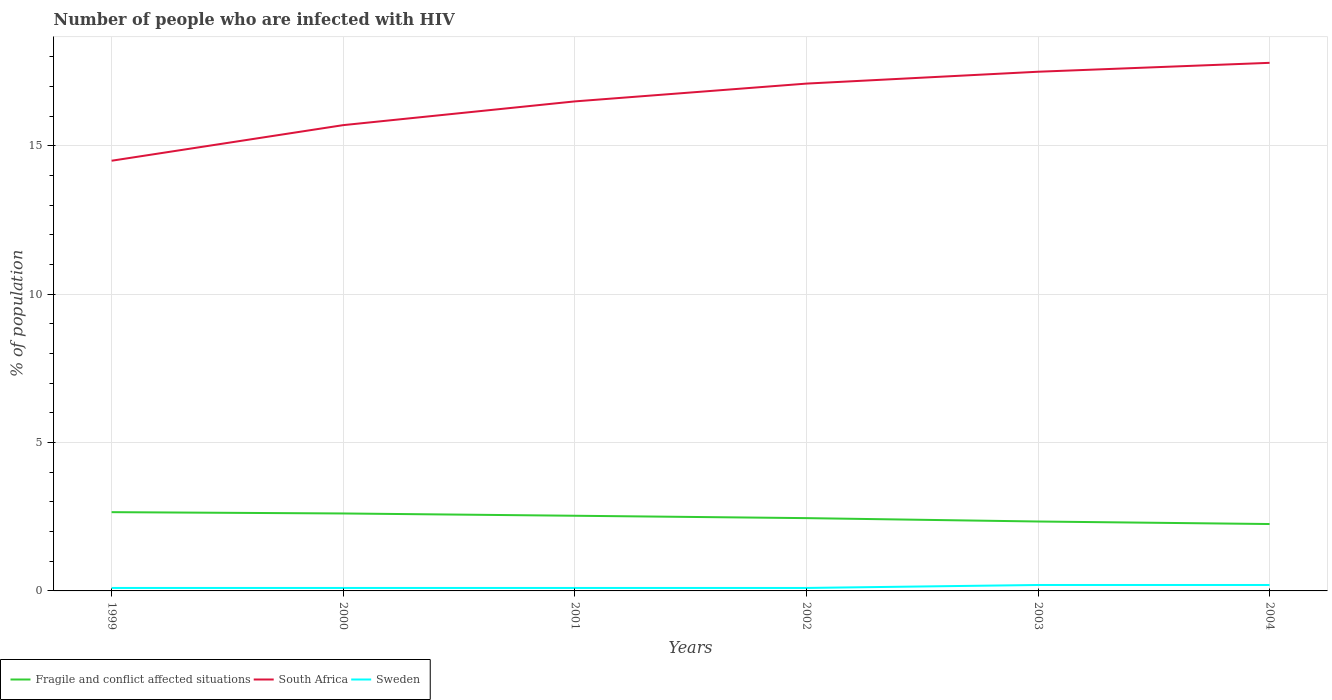Is the number of lines equal to the number of legend labels?
Give a very brief answer. Yes. Across all years, what is the maximum percentage of HIV infected population in in Fragile and conflict affected situations?
Your answer should be very brief. 2.25. In which year was the percentage of HIV infected population in in Sweden maximum?
Provide a short and direct response. 1999. What is the total percentage of HIV infected population in in South Africa in the graph?
Your response must be concise. -3.3. What is the difference between the highest and the second highest percentage of HIV infected population in in South Africa?
Provide a short and direct response. 3.3. Is the percentage of HIV infected population in in South Africa strictly greater than the percentage of HIV infected population in in Sweden over the years?
Offer a very short reply. No. How many lines are there?
Offer a terse response. 3. How many years are there in the graph?
Give a very brief answer. 6. Are the values on the major ticks of Y-axis written in scientific E-notation?
Provide a succinct answer. No. Does the graph contain any zero values?
Offer a very short reply. No. Does the graph contain grids?
Keep it short and to the point. Yes. How many legend labels are there?
Provide a short and direct response. 3. What is the title of the graph?
Offer a terse response. Number of people who are infected with HIV. What is the label or title of the X-axis?
Provide a short and direct response. Years. What is the label or title of the Y-axis?
Your answer should be very brief. % of population. What is the % of population in Fragile and conflict affected situations in 1999?
Your answer should be very brief. 2.66. What is the % of population in Fragile and conflict affected situations in 2000?
Provide a succinct answer. 2.61. What is the % of population of South Africa in 2000?
Offer a very short reply. 15.7. What is the % of population of Sweden in 2000?
Your response must be concise. 0.1. What is the % of population of Fragile and conflict affected situations in 2001?
Give a very brief answer. 2.53. What is the % of population in South Africa in 2001?
Offer a terse response. 16.5. What is the % of population in Fragile and conflict affected situations in 2002?
Give a very brief answer. 2.45. What is the % of population of Fragile and conflict affected situations in 2003?
Offer a terse response. 2.34. What is the % of population in South Africa in 2003?
Your answer should be very brief. 17.5. What is the % of population of Fragile and conflict affected situations in 2004?
Offer a very short reply. 2.25. What is the % of population in South Africa in 2004?
Ensure brevity in your answer.  17.8. Across all years, what is the maximum % of population in Fragile and conflict affected situations?
Ensure brevity in your answer.  2.66. Across all years, what is the maximum % of population in South Africa?
Your answer should be compact. 17.8. Across all years, what is the minimum % of population in Fragile and conflict affected situations?
Keep it short and to the point. 2.25. Across all years, what is the minimum % of population of South Africa?
Make the answer very short. 14.5. Across all years, what is the minimum % of population in Sweden?
Offer a terse response. 0.1. What is the total % of population in Fragile and conflict affected situations in the graph?
Your answer should be compact. 14.85. What is the total % of population in South Africa in the graph?
Provide a succinct answer. 99.1. What is the total % of population in Sweden in the graph?
Ensure brevity in your answer.  0.8. What is the difference between the % of population of Fragile and conflict affected situations in 1999 and that in 2000?
Your answer should be compact. 0.04. What is the difference between the % of population of Fragile and conflict affected situations in 1999 and that in 2001?
Provide a short and direct response. 0.12. What is the difference between the % of population in Fragile and conflict affected situations in 1999 and that in 2002?
Keep it short and to the point. 0.2. What is the difference between the % of population in South Africa in 1999 and that in 2002?
Keep it short and to the point. -2.6. What is the difference between the % of population in Sweden in 1999 and that in 2002?
Provide a succinct answer. 0. What is the difference between the % of population in Fragile and conflict affected situations in 1999 and that in 2003?
Provide a succinct answer. 0.31. What is the difference between the % of population of South Africa in 1999 and that in 2003?
Offer a very short reply. -3. What is the difference between the % of population of Fragile and conflict affected situations in 1999 and that in 2004?
Provide a succinct answer. 0.4. What is the difference between the % of population in South Africa in 1999 and that in 2004?
Offer a very short reply. -3.3. What is the difference between the % of population of Sweden in 1999 and that in 2004?
Ensure brevity in your answer.  -0.1. What is the difference between the % of population in Fragile and conflict affected situations in 2000 and that in 2001?
Keep it short and to the point. 0.08. What is the difference between the % of population of Fragile and conflict affected situations in 2000 and that in 2002?
Offer a very short reply. 0.16. What is the difference between the % of population of South Africa in 2000 and that in 2002?
Offer a very short reply. -1.4. What is the difference between the % of population in Fragile and conflict affected situations in 2000 and that in 2003?
Offer a very short reply. 0.27. What is the difference between the % of population in South Africa in 2000 and that in 2003?
Offer a terse response. -1.8. What is the difference between the % of population of Sweden in 2000 and that in 2003?
Make the answer very short. -0.1. What is the difference between the % of population in Fragile and conflict affected situations in 2000 and that in 2004?
Ensure brevity in your answer.  0.36. What is the difference between the % of population in South Africa in 2000 and that in 2004?
Offer a terse response. -2.1. What is the difference between the % of population in Fragile and conflict affected situations in 2001 and that in 2002?
Your response must be concise. 0.08. What is the difference between the % of population of South Africa in 2001 and that in 2002?
Give a very brief answer. -0.6. What is the difference between the % of population of Fragile and conflict affected situations in 2001 and that in 2003?
Make the answer very short. 0.19. What is the difference between the % of population in Sweden in 2001 and that in 2003?
Make the answer very short. -0.1. What is the difference between the % of population in Fragile and conflict affected situations in 2001 and that in 2004?
Ensure brevity in your answer.  0.28. What is the difference between the % of population in Fragile and conflict affected situations in 2002 and that in 2003?
Provide a short and direct response. 0.11. What is the difference between the % of population of South Africa in 2002 and that in 2003?
Provide a short and direct response. -0.4. What is the difference between the % of population of Sweden in 2002 and that in 2003?
Provide a short and direct response. -0.1. What is the difference between the % of population in Fragile and conflict affected situations in 2002 and that in 2004?
Your response must be concise. 0.2. What is the difference between the % of population of South Africa in 2002 and that in 2004?
Provide a succinct answer. -0.7. What is the difference between the % of population of Sweden in 2002 and that in 2004?
Give a very brief answer. -0.1. What is the difference between the % of population of Fragile and conflict affected situations in 2003 and that in 2004?
Make the answer very short. 0.09. What is the difference between the % of population in South Africa in 2003 and that in 2004?
Your answer should be very brief. -0.3. What is the difference between the % of population in Fragile and conflict affected situations in 1999 and the % of population in South Africa in 2000?
Offer a very short reply. -13.04. What is the difference between the % of population of Fragile and conflict affected situations in 1999 and the % of population of Sweden in 2000?
Your response must be concise. 2.56. What is the difference between the % of population in Fragile and conflict affected situations in 1999 and the % of population in South Africa in 2001?
Provide a succinct answer. -13.84. What is the difference between the % of population of Fragile and conflict affected situations in 1999 and the % of population of Sweden in 2001?
Provide a short and direct response. 2.56. What is the difference between the % of population of Fragile and conflict affected situations in 1999 and the % of population of South Africa in 2002?
Your answer should be very brief. -14.44. What is the difference between the % of population in Fragile and conflict affected situations in 1999 and the % of population in Sweden in 2002?
Provide a short and direct response. 2.56. What is the difference between the % of population of South Africa in 1999 and the % of population of Sweden in 2002?
Offer a terse response. 14.4. What is the difference between the % of population in Fragile and conflict affected situations in 1999 and the % of population in South Africa in 2003?
Your answer should be very brief. -14.84. What is the difference between the % of population in Fragile and conflict affected situations in 1999 and the % of population in Sweden in 2003?
Your response must be concise. 2.46. What is the difference between the % of population of South Africa in 1999 and the % of population of Sweden in 2003?
Your response must be concise. 14.3. What is the difference between the % of population of Fragile and conflict affected situations in 1999 and the % of population of South Africa in 2004?
Offer a very short reply. -15.14. What is the difference between the % of population of Fragile and conflict affected situations in 1999 and the % of population of Sweden in 2004?
Keep it short and to the point. 2.46. What is the difference between the % of population in Fragile and conflict affected situations in 2000 and the % of population in South Africa in 2001?
Keep it short and to the point. -13.89. What is the difference between the % of population in Fragile and conflict affected situations in 2000 and the % of population in Sweden in 2001?
Make the answer very short. 2.51. What is the difference between the % of population in Fragile and conflict affected situations in 2000 and the % of population in South Africa in 2002?
Your answer should be very brief. -14.49. What is the difference between the % of population in Fragile and conflict affected situations in 2000 and the % of population in Sweden in 2002?
Provide a succinct answer. 2.51. What is the difference between the % of population of South Africa in 2000 and the % of population of Sweden in 2002?
Your answer should be compact. 15.6. What is the difference between the % of population in Fragile and conflict affected situations in 2000 and the % of population in South Africa in 2003?
Offer a very short reply. -14.89. What is the difference between the % of population in Fragile and conflict affected situations in 2000 and the % of population in Sweden in 2003?
Offer a terse response. 2.41. What is the difference between the % of population in South Africa in 2000 and the % of population in Sweden in 2003?
Ensure brevity in your answer.  15.5. What is the difference between the % of population of Fragile and conflict affected situations in 2000 and the % of population of South Africa in 2004?
Keep it short and to the point. -15.19. What is the difference between the % of population of Fragile and conflict affected situations in 2000 and the % of population of Sweden in 2004?
Ensure brevity in your answer.  2.41. What is the difference between the % of population in South Africa in 2000 and the % of population in Sweden in 2004?
Provide a succinct answer. 15.5. What is the difference between the % of population in Fragile and conflict affected situations in 2001 and the % of population in South Africa in 2002?
Keep it short and to the point. -14.57. What is the difference between the % of population in Fragile and conflict affected situations in 2001 and the % of population in Sweden in 2002?
Your response must be concise. 2.43. What is the difference between the % of population in Fragile and conflict affected situations in 2001 and the % of population in South Africa in 2003?
Offer a very short reply. -14.97. What is the difference between the % of population in Fragile and conflict affected situations in 2001 and the % of population in Sweden in 2003?
Give a very brief answer. 2.33. What is the difference between the % of population of Fragile and conflict affected situations in 2001 and the % of population of South Africa in 2004?
Offer a very short reply. -15.27. What is the difference between the % of population in Fragile and conflict affected situations in 2001 and the % of population in Sweden in 2004?
Make the answer very short. 2.33. What is the difference between the % of population in South Africa in 2001 and the % of population in Sweden in 2004?
Keep it short and to the point. 16.3. What is the difference between the % of population of Fragile and conflict affected situations in 2002 and the % of population of South Africa in 2003?
Provide a short and direct response. -15.05. What is the difference between the % of population of Fragile and conflict affected situations in 2002 and the % of population of Sweden in 2003?
Your response must be concise. 2.25. What is the difference between the % of population in Fragile and conflict affected situations in 2002 and the % of population in South Africa in 2004?
Provide a succinct answer. -15.35. What is the difference between the % of population of Fragile and conflict affected situations in 2002 and the % of population of Sweden in 2004?
Make the answer very short. 2.25. What is the difference between the % of population in Fragile and conflict affected situations in 2003 and the % of population in South Africa in 2004?
Your answer should be compact. -15.46. What is the difference between the % of population in Fragile and conflict affected situations in 2003 and the % of population in Sweden in 2004?
Your answer should be compact. 2.14. What is the average % of population of Fragile and conflict affected situations per year?
Offer a terse response. 2.47. What is the average % of population in South Africa per year?
Your response must be concise. 16.52. What is the average % of population in Sweden per year?
Keep it short and to the point. 0.13. In the year 1999, what is the difference between the % of population in Fragile and conflict affected situations and % of population in South Africa?
Ensure brevity in your answer.  -11.84. In the year 1999, what is the difference between the % of population of Fragile and conflict affected situations and % of population of Sweden?
Provide a short and direct response. 2.56. In the year 1999, what is the difference between the % of population of South Africa and % of population of Sweden?
Ensure brevity in your answer.  14.4. In the year 2000, what is the difference between the % of population of Fragile and conflict affected situations and % of population of South Africa?
Your answer should be compact. -13.09. In the year 2000, what is the difference between the % of population of Fragile and conflict affected situations and % of population of Sweden?
Offer a very short reply. 2.51. In the year 2001, what is the difference between the % of population in Fragile and conflict affected situations and % of population in South Africa?
Provide a short and direct response. -13.97. In the year 2001, what is the difference between the % of population in Fragile and conflict affected situations and % of population in Sweden?
Keep it short and to the point. 2.43. In the year 2001, what is the difference between the % of population in South Africa and % of population in Sweden?
Provide a short and direct response. 16.4. In the year 2002, what is the difference between the % of population of Fragile and conflict affected situations and % of population of South Africa?
Make the answer very short. -14.65. In the year 2002, what is the difference between the % of population of Fragile and conflict affected situations and % of population of Sweden?
Provide a succinct answer. 2.35. In the year 2002, what is the difference between the % of population of South Africa and % of population of Sweden?
Offer a terse response. 17. In the year 2003, what is the difference between the % of population in Fragile and conflict affected situations and % of population in South Africa?
Ensure brevity in your answer.  -15.16. In the year 2003, what is the difference between the % of population of Fragile and conflict affected situations and % of population of Sweden?
Offer a very short reply. 2.14. In the year 2004, what is the difference between the % of population of Fragile and conflict affected situations and % of population of South Africa?
Offer a very short reply. -15.55. In the year 2004, what is the difference between the % of population in Fragile and conflict affected situations and % of population in Sweden?
Make the answer very short. 2.05. What is the ratio of the % of population of South Africa in 1999 to that in 2000?
Make the answer very short. 0.92. What is the ratio of the % of population in Sweden in 1999 to that in 2000?
Make the answer very short. 1. What is the ratio of the % of population of Fragile and conflict affected situations in 1999 to that in 2001?
Offer a terse response. 1.05. What is the ratio of the % of population in South Africa in 1999 to that in 2001?
Your answer should be very brief. 0.88. What is the ratio of the % of population in Sweden in 1999 to that in 2001?
Offer a terse response. 1. What is the ratio of the % of population in Fragile and conflict affected situations in 1999 to that in 2002?
Your response must be concise. 1.08. What is the ratio of the % of population in South Africa in 1999 to that in 2002?
Keep it short and to the point. 0.85. What is the ratio of the % of population in Fragile and conflict affected situations in 1999 to that in 2003?
Keep it short and to the point. 1.13. What is the ratio of the % of population of South Africa in 1999 to that in 2003?
Ensure brevity in your answer.  0.83. What is the ratio of the % of population in Sweden in 1999 to that in 2003?
Ensure brevity in your answer.  0.5. What is the ratio of the % of population in Fragile and conflict affected situations in 1999 to that in 2004?
Your answer should be very brief. 1.18. What is the ratio of the % of population in South Africa in 1999 to that in 2004?
Give a very brief answer. 0.81. What is the ratio of the % of population in Fragile and conflict affected situations in 2000 to that in 2001?
Ensure brevity in your answer.  1.03. What is the ratio of the % of population in South Africa in 2000 to that in 2001?
Your response must be concise. 0.95. What is the ratio of the % of population of Fragile and conflict affected situations in 2000 to that in 2002?
Give a very brief answer. 1.06. What is the ratio of the % of population of South Africa in 2000 to that in 2002?
Your answer should be very brief. 0.92. What is the ratio of the % of population of Sweden in 2000 to that in 2002?
Offer a very short reply. 1. What is the ratio of the % of population in Fragile and conflict affected situations in 2000 to that in 2003?
Ensure brevity in your answer.  1.12. What is the ratio of the % of population in South Africa in 2000 to that in 2003?
Your answer should be very brief. 0.9. What is the ratio of the % of population in Sweden in 2000 to that in 2003?
Your answer should be compact. 0.5. What is the ratio of the % of population of Fragile and conflict affected situations in 2000 to that in 2004?
Your response must be concise. 1.16. What is the ratio of the % of population of South Africa in 2000 to that in 2004?
Your answer should be very brief. 0.88. What is the ratio of the % of population in Sweden in 2000 to that in 2004?
Your answer should be very brief. 0.5. What is the ratio of the % of population of Fragile and conflict affected situations in 2001 to that in 2002?
Give a very brief answer. 1.03. What is the ratio of the % of population in South Africa in 2001 to that in 2002?
Provide a succinct answer. 0.96. What is the ratio of the % of population of Sweden in 2001 to that in 2002?
Keep it short and to the point. 1. What is the ratio of the % of population in Fragile and conflict affected situations in 2001 to that in 2003?
Offer a very short reply. 1.08. What is the ratio of the % of population of South Africa in 2001 to that in 2003?
Make the answer very short. 0.94. What is the ratio of the % of population in Sweden in 2001 to that in 2003?
Provide a succinct answer. 0.5. What is the ratio of the % of population of Fragile and conflict affected situations in 2001 to that in 2004?
Provide a short and direct response. 1.12. What is the ratio of the % of population in South Africa in 2001 to that in 2004?
Make the answer very short. 0.93. What is the ratio of the % of population in Fragile and conflict affected situations in 2002 to that in 2003?
Your response must be concise. 1.05. What is the ratio of the % of population of South Africa in 2002 to that in 2003?
Give a very brief answer. 0.98. What is the ratio of the % of population of Fragile and conflict affected situations in 2002 to that in 2004?
Offer a terse response. 1.09. What is the ratio of the % of population in South Africa in 2002 to that in 2004?
Make the answer very short. 0.96. What is the ratio of the % of population of Sweden in 2002 to that in 2004?
Ensure brevity in your answer.  0.5. What is the ratio of the % of population in Fragile and conflict affected situations in 2003 to that in 2004?
Offer a terse response. 1.04. What is the ratio of the % of population in South Africa in 2003 to that in 2004?
Give a very brief answer. 0.98. What is the difference between the highest and the second highest % of population of Fragile and conflict affected situations?
Your answer should be compact. 0.04. What is the difference between the highest and the second highest % of population in South Africa?
Your answer should be very brief. 0.3. What is the difference between the highest and the lowest % of population of Fragile and conflict affected situations?
Your response must be concise. 0.4. What is the difference between the highest and the lowest % of population of Sweden?
Keep it short and to the point. 0.1. 